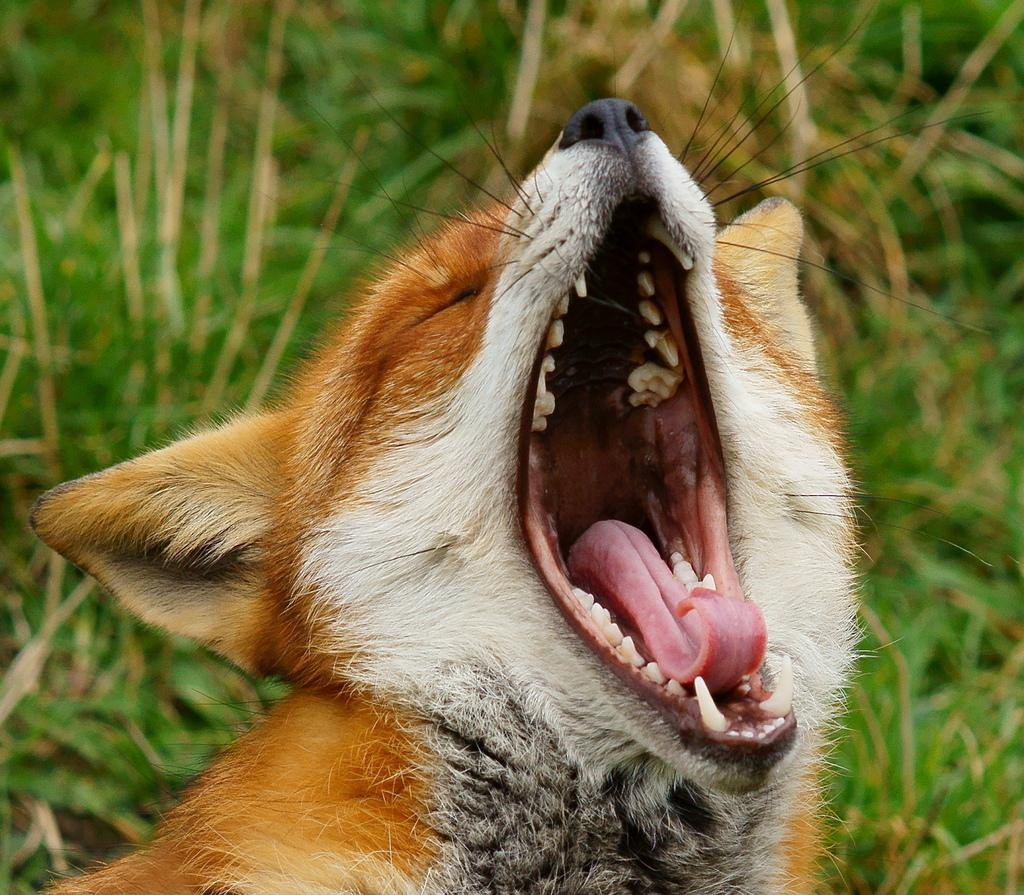What type of animal is in the image? The specific type of animal cannot be determined from the provided facts. What is the animal doing in the image? The animal's mouth is open in the image. What can be seen in the background of the image? The background of the image is blurred. What else is visible in the image besides the animal? There are plants visible in the image. What type of sign can be seen in the image? There is no sign present in the image. What season is depicted in the image? The provided facts do not indicate any specific season, such as summer. 